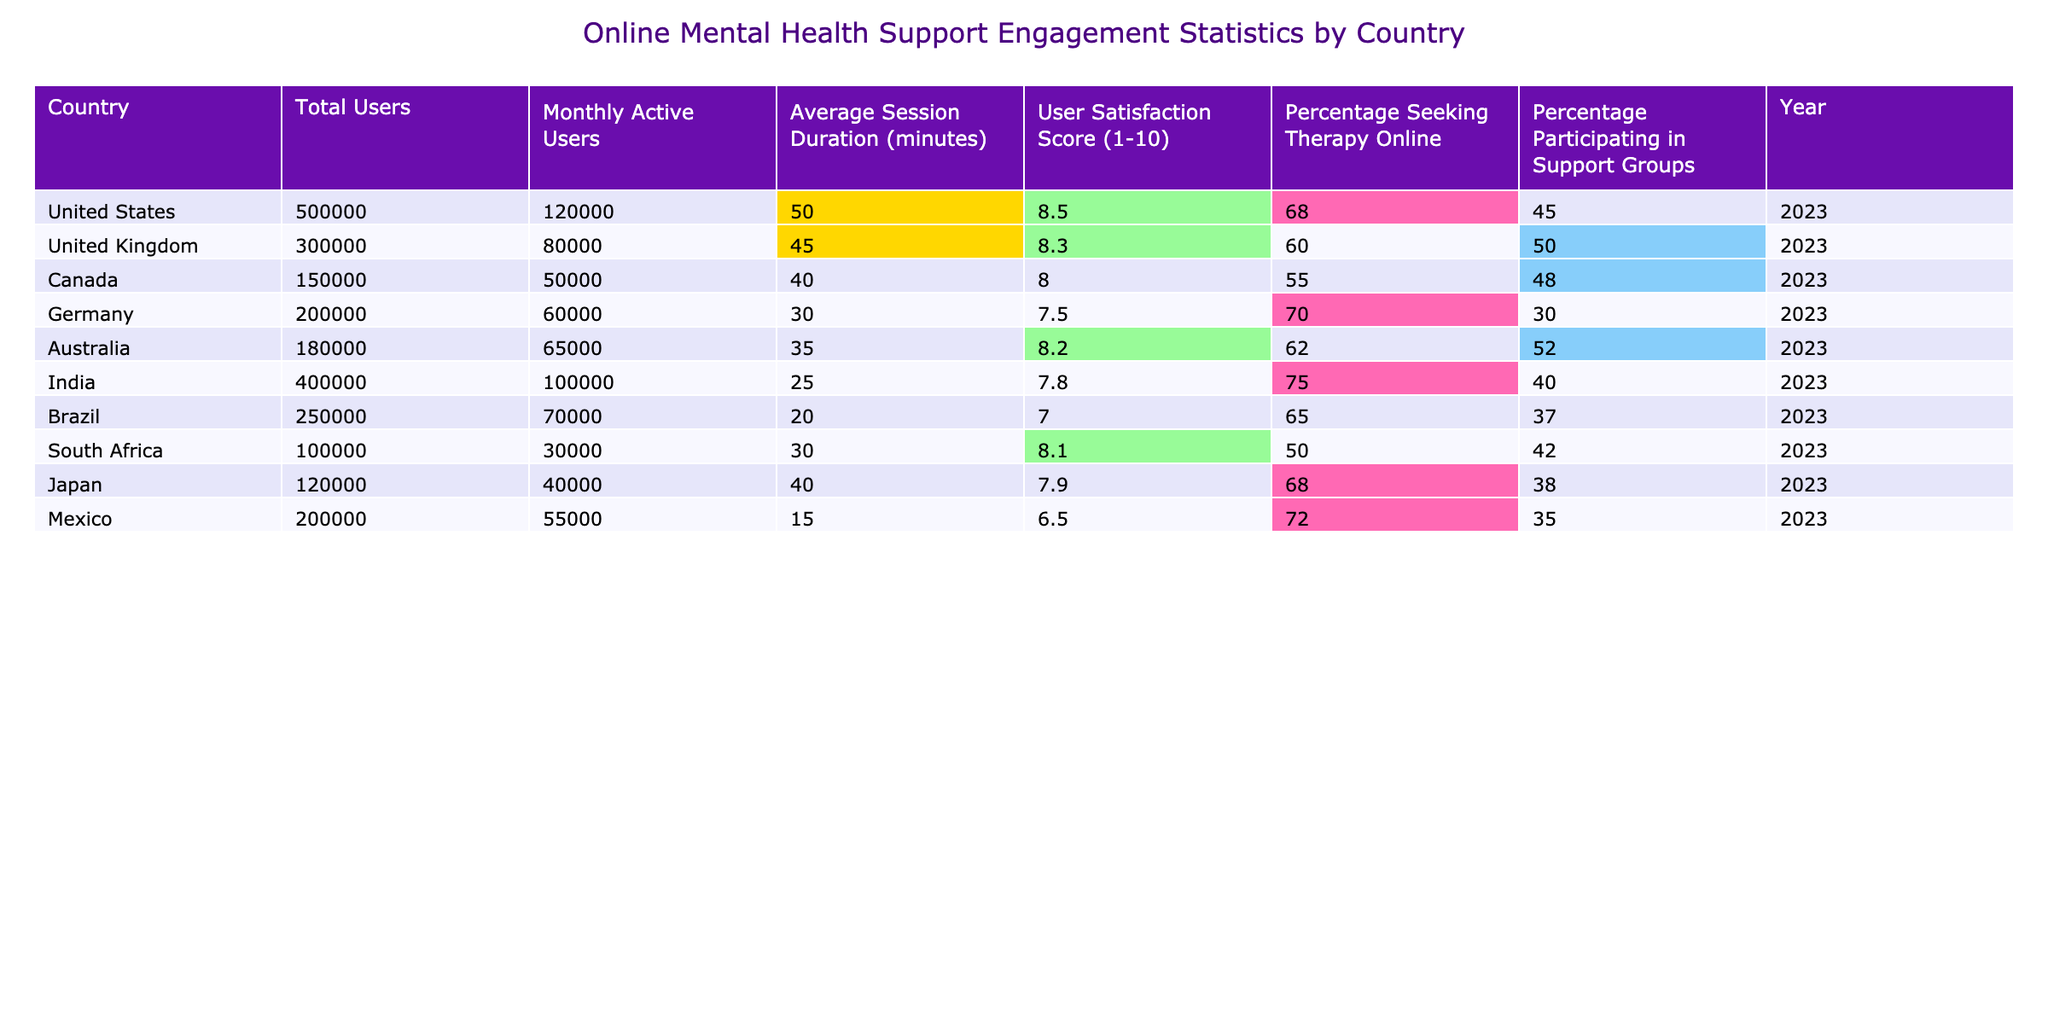What country has the highest user satisfaction score? The User Satisfaction Score for each country is listed in the table. Checking those values, the United States has the highest score of 8.5.
Answer: United States What percentage of users in Canada seek therapy online? The table shows that 55% of users in Canada are seeking therapy online.
Answer: 55% Which country has the longest average session duration? Looking at the Average Session Duration values, the United States has the longest duration at 50 minutes.
Answer: United States How many total users are there in India and Brazil combined? The total users in India are 400,000 and in Brazil are 250,000. Adding these gives 400,000 + 250,000 = 650,000 total users.
Answer: 650000 Is the percentage of users participating in support groups higher in Australia than in Germany? Australia has 52% of users participating in support groups, while Germany has 30%. Since 52% is higher than 30%, the answer is yes.
Answer: Yes What is the average user satisfaction score across all countries? The user satisfaction scores from each country sum to (8.5 + 8.3 + 8.0 + 7.5 + 8.2 + 7.8 + 7.0 + 8.1 + 7.9 + 6.5) = 78.7. There are 10 countries, so the average is 78.7 / 10 = 7.87.
Answer: 7.87 Which country has the lowest percentage of users seeking therapy online? The table shows that South Africa has the lowest percentage at 50%.
Answer: South Africa If we exclude the United States, what is the combined average session duration for the other countries? The session durations for the other countries are (45 + 40 + 30 + 35 + 25 + 20 + 30 + 40 + 15). Summing these gives 330 minutes, and there are 9 countries. Therefore, the average is 330 / 9 = 36.67 minutes.
Answer: 36.67 Are there more total users in the UK or Canada? The UK has 300,000 total users, while Canada has 150,000. Comparing these values, the UK has more total users.
Answer: UK How does the percentage seeking therapy online in India compare to the average across all countries? India has 75% seeking therapy online. Calculating the average of the percentages: (68 + 60 + 55 + 70 + 62 + 75 + 65 + 50 + 68 + 72) = 675% total, spread across 10 countries gives an average of 67.5%. Since 75% is higher than 67.5%, India is above average.
Answer: Above average 